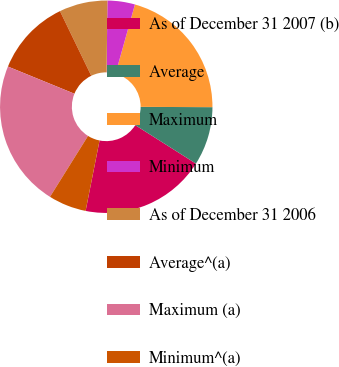<chart> <loc_0><loc_0><loc_500><loc_500><pie_chart><fcel>As of December 31 2007 (b)<fcel>Average<fcel>Maximum<fcel>Minimum<fcel>As of December 31 2006<fcel>Average^(a)<fcel>Maximum (a)<fcel>Minimum^(a)<nl><fcel>19.12%<fcel>8.93%<fcel>20.71%<fcel>4.18%<fcel>7.35%<fcel>11.65%<fcel>22.29%<fcel>5.77%<nl></chart> 